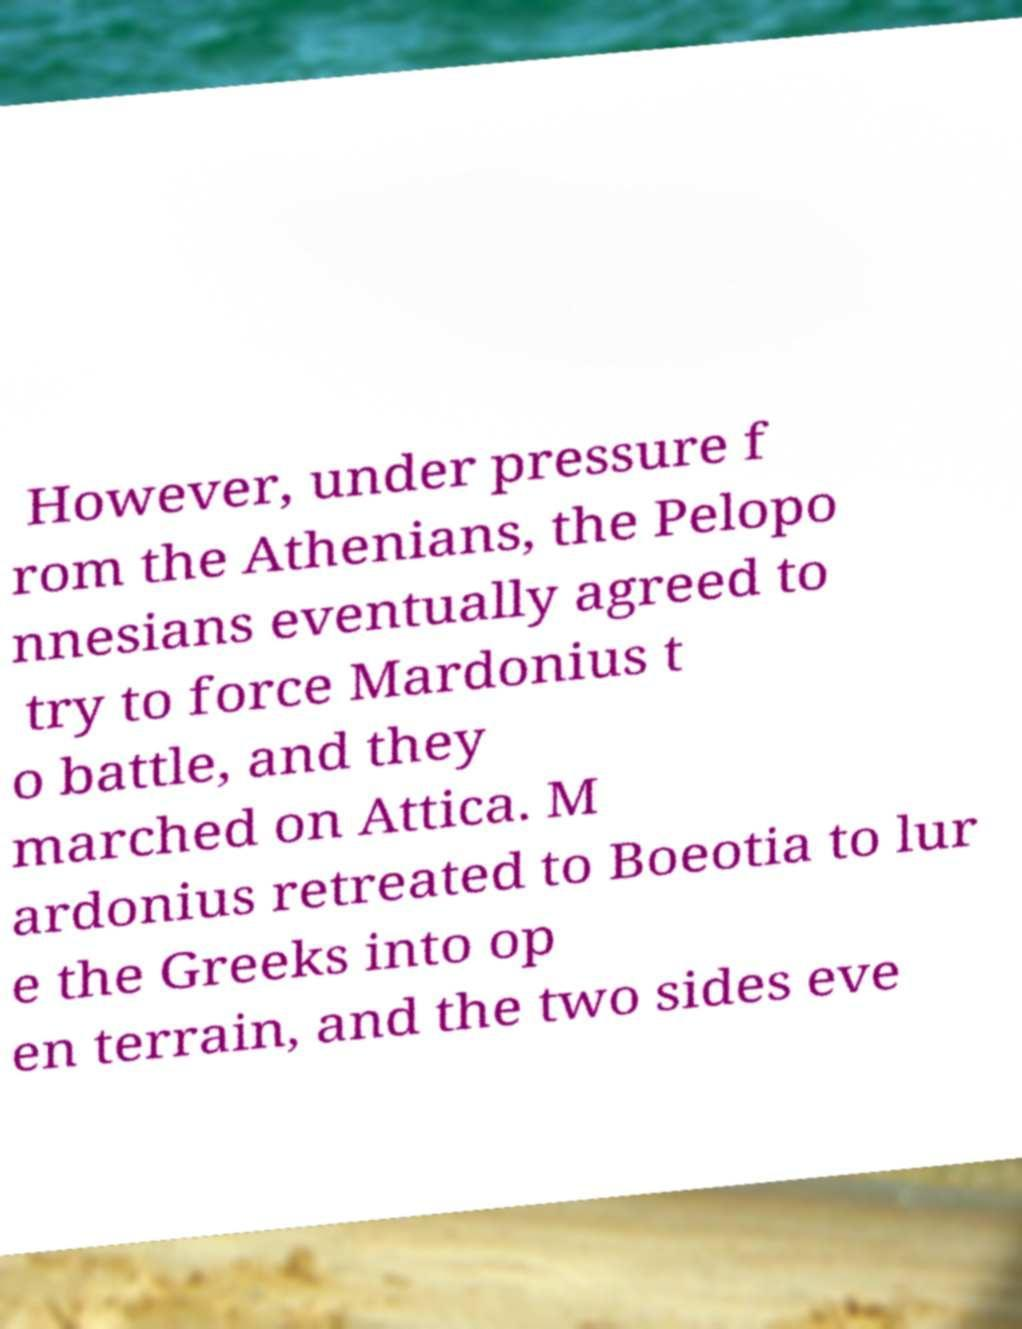Could you extract and type out the text from this image? However, under pressure f rom the Athenians, the Pelopo nnesians eventually agreed to try to force Mardonius t o battle, and they marched on Attica. M ardonius retreated to Boeotia to lur e the Greeks into op en terrain, and the two sides eve 